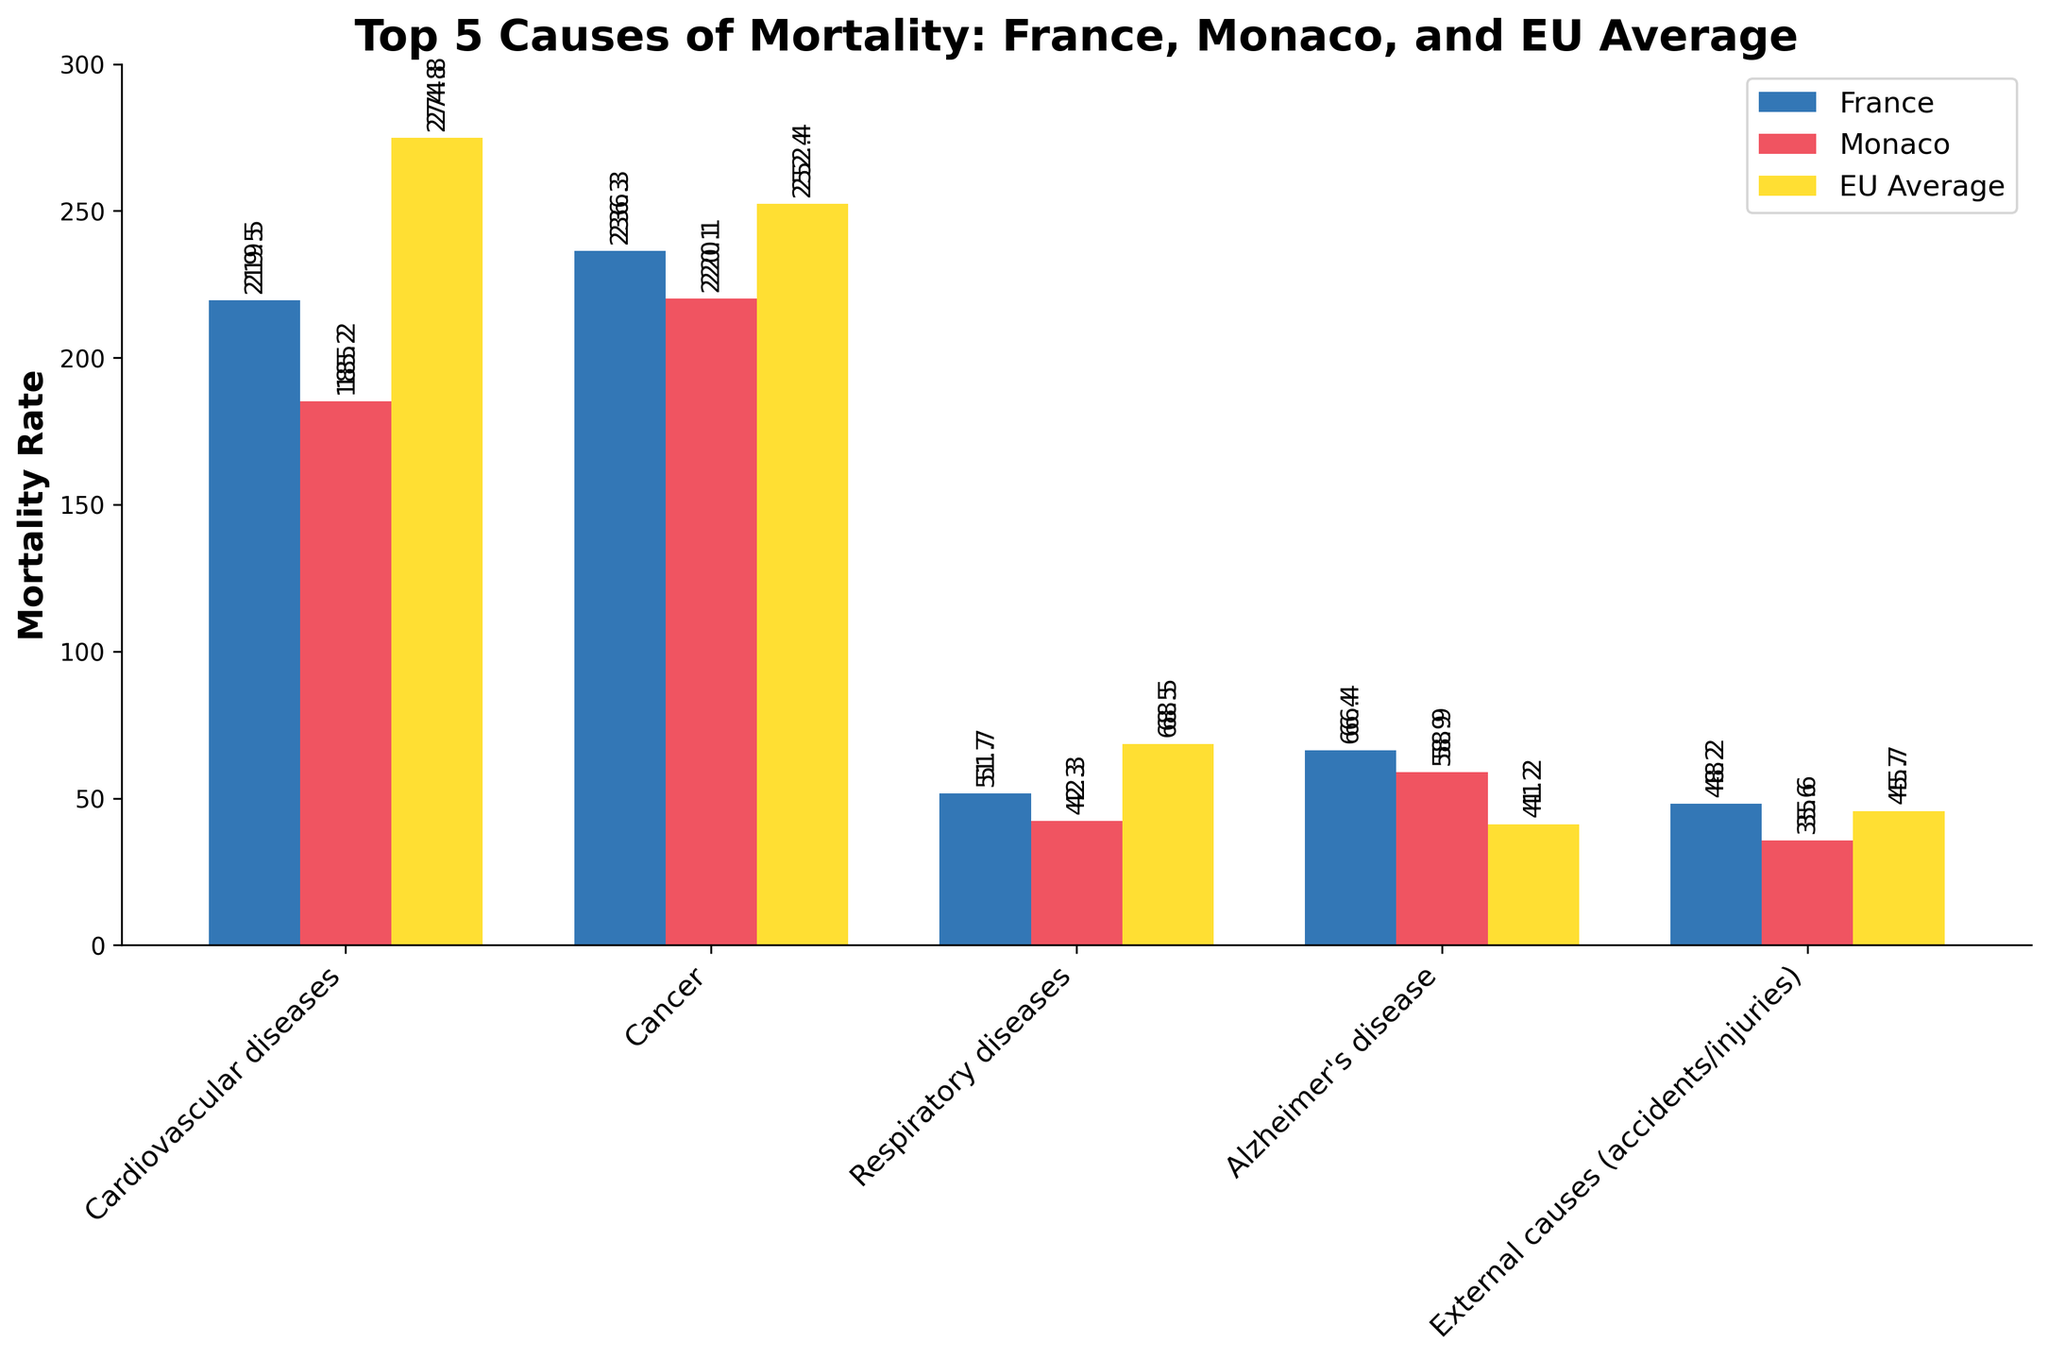What is the leading cause of mortality in France? The height of the bars indicates the mortality rates. The bar representing Cancer is the tallest for France, showing a rate of 236.3, making it the leading cause of mortality.
Answer: Cancer Which country, France or Monaco, has a higher mortality rate for cardiovascular diseases? By comparing the heights of the bars for cardiovascular diseases, we see that France's bar is taller with a rate of 219.5 compared to Monaco's rate of 185.2.
Answer: France How does Monaco's mortality rate for Alzheimer's disease compare to the EU Average? The bar for Alzheimer's disease in Monaco is taller than the bar for the EU Average. Monaco has a rate of 58.9, whereas the EU Average is 41.2.
Answer: Monaco's rate is higher Which cause of mortality in Monaco has the lowest rate? By examining the shortest bar among the five causes, we see that External causes (accidents/injuries) has the lowest rate at 35.6.
Answer: External causes (accidents/injuries) What is the difference in the mortality rate for respiratory diseases between France and the EU Average? The bar for France (51.7) is shorter than the bar for the EU Average (68.5). The difference is calculated as 68.5 - 51.7 = 16.8.
Answer: 16.8 What's the average mortality rate for the top 5 causes in Monaco? Add the rates for Monaco (185.2 + 220.1 + 42.3 + 58.9 + 35.6 = 542.1) and divide by 5 (number of causes). 542.1 / 5 = 108.42
Answer: 108.42 Compare the mortality rates for cancer in France and the EU Average. Which one is lower, and by how much? The rate for France is 236.3 and for the EU Average is 252.4. The EU Average is higher. Difference is 252.4 - 236.3 = 16.1.
Answer: France is lower by 16.1 What is the total mortality rate for all causes in France? Sum the rates for France: 219.5 + 236.3 + 51.7 + 66.4 + 48.2 = 622.1.
Answer: 622.1 Which country has a lower mortality rate for external causes, Monaco or the EU Average? Comparing the heights of the bars for external causes, Monaco (35.6) is shorter than the EU Average (45.7).
Answer: Monaco 